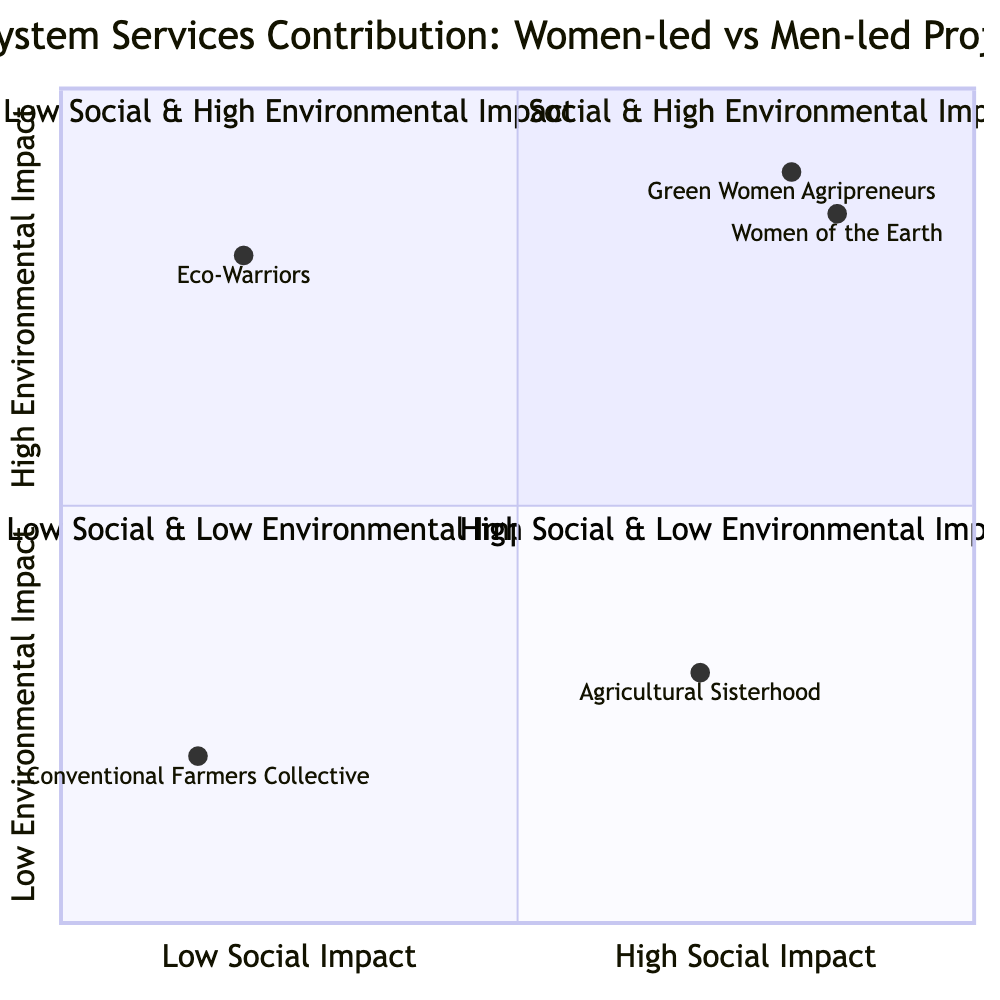What project is located in Kenya? The diagram shows "Green Women Agripreneurs" in the Top-Right quadrant, which represents high social and environmental impact projects, and it is specifically located in Kenya.
Answer: Green Women Agripreneurs Which project has the highest social impact score? Among the projects displayed in the diagram, "Women of the Earth" has the highest social impact score at 0.85, which is indicated by its position in the Top-Right quadrant.
Answer: Women of the Earth How many men-led projects are represented in the diagram? The diagram includes two men-led projects: "Eco-Warriors" located in Brazil and "Conventional Farmers Collective" located in Australia, which are identified in the Top-Left and Bottom-Left quadrants, respectively.
Answer: 2 Which quadrant contains the project "Agricultural Sisterhood"? "Agricultural Sisterhood" is located in the Bottom-Right quadrant of the diagram, which represents projects with high social impact but low environmental impact.
Answer: Bottom-Right What is the key contribution of "Eco-Warriors"? The project "Eco-Warriors," led by a male in Brazil, primarily focuses on reforestation efforts, which is the primary key contribution noted in the diagram for this project.
Answer: Reforestation efforts How does the environmental impact of "Conventional Farmers Collective" compare to that of "Agricultural Sisterhood"? "Conventional Farmers Collective" has a low environmental impact score of 0.2, whereas "Agricultural Sisterhood" has a moderate environmental impact score of 0.3; therefore, "Agricultural Sisterhood" has a slightly higher environmental impact.
Answer: Higher environmental impact Which project provides empowerment through education and training? "Women of the Earth," located in India and led by women, provides empowerment through education and training as part of its key contributions, as mentioned in the diagram.
Answer: Women of the Earth What type of project is "Green Women Agripreneurs"? "Green Women Agripreneurs" is categorized as a women-led project with high social and environmental impact, based on its positioning in the Top-Right quadrant of the diagram.
Answer: Women-led project 